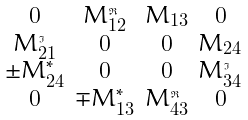<formula> <loc_0><loc_0><loc_500><loc_500>\begin{smallmatrix} \\ 0 & M _ { 1 2 } ^ { \Re } & M _ { 1 3 } & 0 \\ M _ { 2 1 } ^ { \Im } & 0 & 0 & M _ { 2 4 } \\ \pm M _ { 2 4 } ^ { * } & 0 & 0 & M _ { 3 4 } ^ { \Im } \\ 0 & \mp M _ { 1 3 } ^ { * } & M _ { 4 3 } ^ { \Re } & 0 \\ \end{smallmatrix}</formula> 